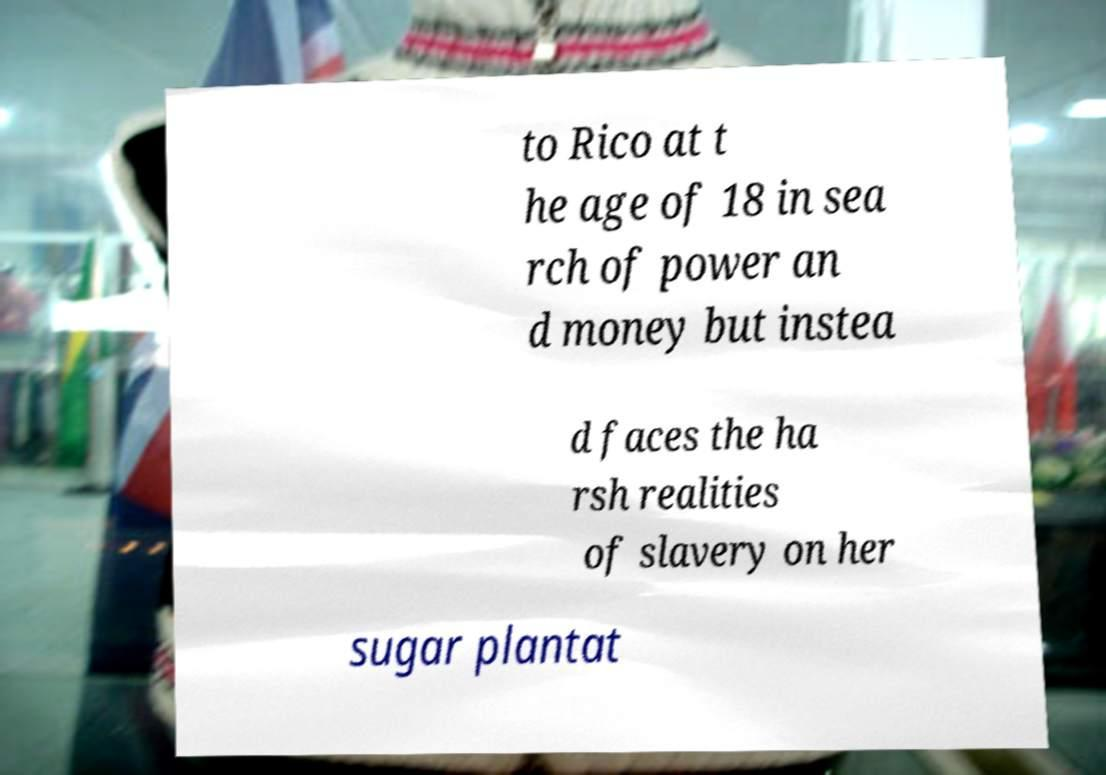Can you read and provide the text displayed in the image?This photo seems to have some interesting text. Can you extract and type it out for me? to Rico at t he age of 18 in sea rch of power an d money but instea d faces the ha rsh realities of slavery on her sugar plantat 